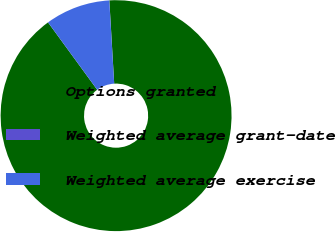Convert chart. <chart><loc_0><loc_0><loc_500><loc_500><pie_chart><fcel>Options granted<fcel>Weighted average grant-date<fcel>Weighted average exercise<nl><fcel>90.9%<fcel>0.01%<fcel>9.09%<nl></chart> 